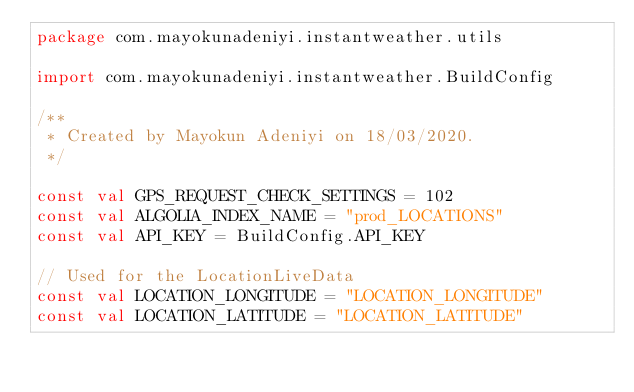<code> <loc_0><loc_0><loc_500><loc_500><_Kotlin_>package com.mayokunadeniyi.instantweather.utils

import com.mayokunadeniyi.instantweather.BuildConfig

/**
 * Created by Mayokun Adeniyi on 18/03/2020.
 */

const val GPS_REQUEST_CHECK_SETTINGS = 102
const val ALGOLIA_INDEX_NAME = "prod_LOCATIONS"
const val API_KEY = BuildConfig.API_KEY

// Used for the LocationLiveData
const val LOCATION_LONGITUDE = "LOCATION_LONGITUDE"
const val LOCATION_LATITUDE = "LOCATION_LATITUDE"
</code> 